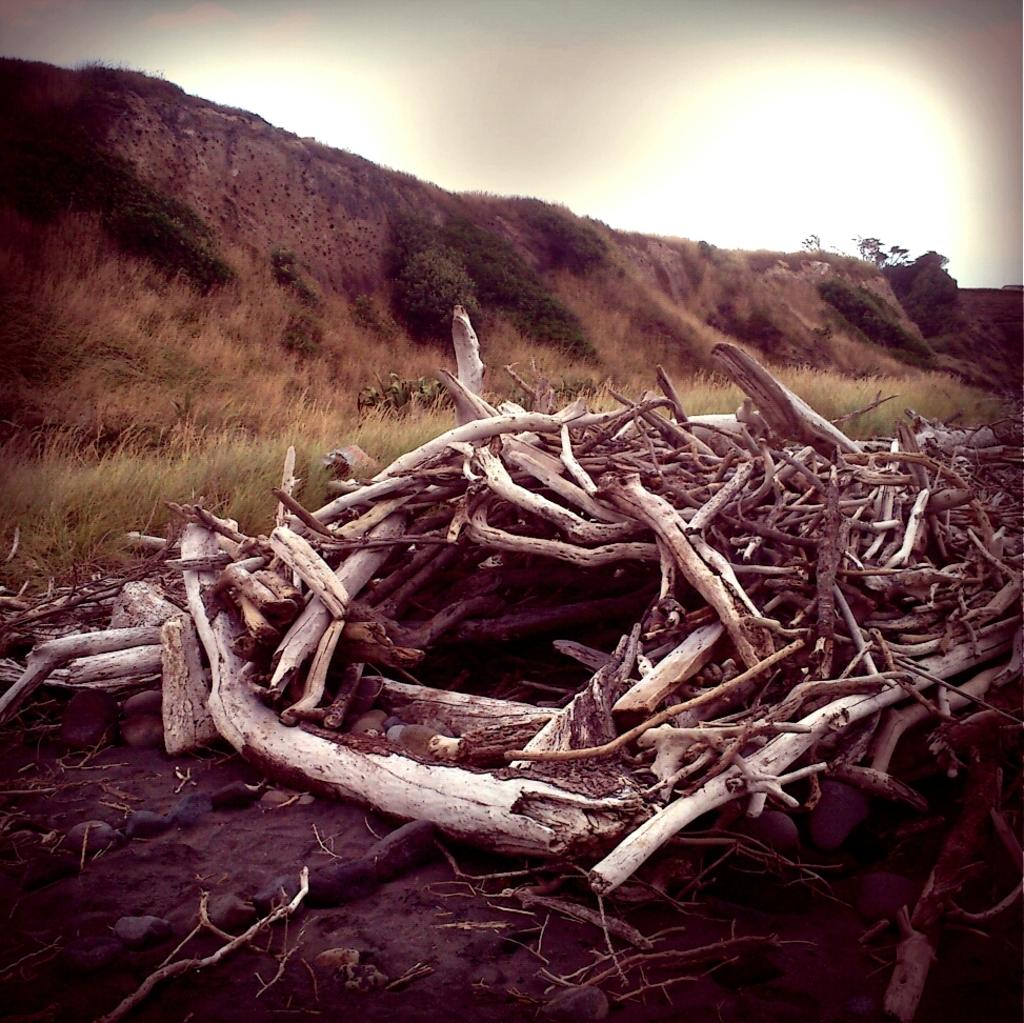What can be seen in the foreground of the image? There are tree branches in the foreground of the image. What type of vegetation is visible in the image? There are trees and grass visible in the image. What is visible at the top of the image? The sky is visible at the top of the image. Where is the grass located in the image? There is grass at the bottom of the image. What type of cabbage can be seen growing in the image? There is no cabbage present in the image; it features tree branches, trees, grass, and the sky. Can you see a chicken walking in the grass in the image? There is no chicken present in the image. 